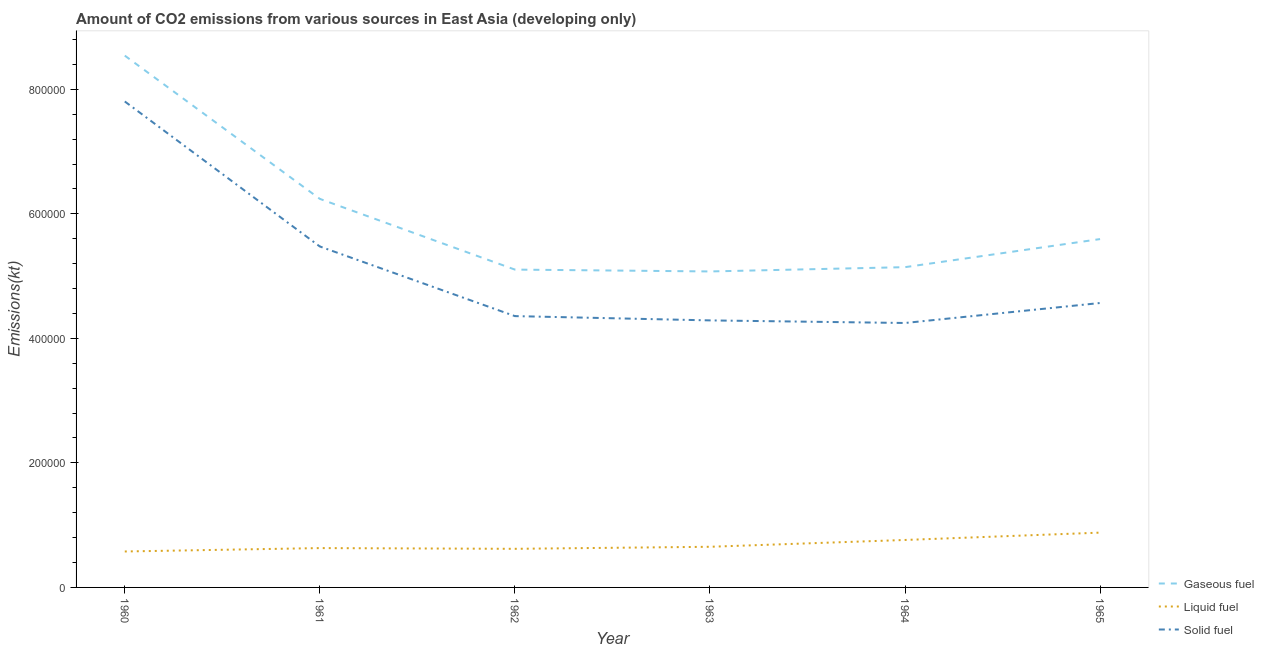Does the line corresponding to amount of co2 emissions from gaseous fuel intersect with the line corresponding to amount of co2 emissions from liquid fuel?
Offer a very short reply. No. Is the number of lines equal to the number of legend labels?
Provide a short and direct response. Yes. What is the amount of co2 emissions from solid fuel in 1962?
Keep it short and to the point. 4.36e+05. Across all years, what is the maximum amount of co2 emissions from gaseous fuel?
Ensure brevity in your answer.  8.54e+05. Across all years, what is the minimum amount of co2 emissions from gaseous fuel?
Offer a very short reply. 5.07e+05. In which year was the amount of co2 emissions from solid fuel maximum?
Keep it short and to the point. 1960. What is the total amount of co2 emissions from liquid fuel in the graph?
Keep it short and to the point. 4.12e+05. What is the difference between the amount of co2 emissions from liquid fuel in 1960 and that in 1965?
Offer a very short reply. -3.03e+04. What is the difference between the amount of co2 emissions from liquid fuel in 1963 and the amount of co2 emissions from gaseous fuel in 1964?
Provide a succinct answer. -4.49e+05. What is the average amount of co2 emissions from gaseous fuel per year?
Offer a terse response. 5.95e+05. In the year 1960, what is the difference between the amount of co2 emissions from gaseous fuel and amount of co2 emissions from solid fuel?
Offer a terse response. 7.36e+04. In how many years, is the amount of co2 emissions from solid fuel greater than 360000 kt?
Your answer should be very brief. 6. What is the ratio of the amount of co2 emissions from solid fuel in 1961 to that in 1962?
Your answer should be very brief. 1.26. Is the difference between the amount of co2 emissions from gaseous fuel in 1963 and 1964 greater than the difference between the amount of co2 emissions from solid fuel in 1963 and 1964?
Make the answer very short. No. What is the difference between the highest and the second highest amount of co2 emissions from gaseous fuel?
Your response must be concise. 2.30e+05. What is the difference between the highest and the lowest amount of co2 emissions from gaseous fuel?
Make the answer very short. 3.47e+05. In how many years, is the amount of co2 emissions from solid fuel greater than the average amount of co2 emissions from solid fuel taken over all years?
Your answer should be very brief. 2. Is the amount of co2 emissions from liquid fuel strictly greater than the amount of co2 emissions from gaseous fuel over the years?
Your response must be concise. No. Is the amount of co2 emissions from gaseous fuel strictly less than the amount of co2 emissions from liquid fuel over the years?
Make the answer very short. No. How many lines are there?
Your answer should be very brief. 3. Are the values on the major ticks of Y-axis written in scientific E-notation?
Your answer should be compact. No. Does the graph contain grids?
Your answer should be compact. No. Where does the legend appear in the graph?
Provide a succinct answer. Bottom right. What is the title of the graph?
Your answer should be very brief. Amount of CO2 emissions from various sources in East Asia (developing only). What is the label or title of the X-axis?
Give a very brief answer. Year. What is the label or title of the Y-axis?
Ensure brevity in your answer.  Emissions(kt). What is the Emissions(kt) of Gaseous fuel in 1960?
Provide a short and direct response. 8.54e+05. What is the Emissions(kt) in Liquid fuel in 1960?
Make the answer very short. 5.77e+04. What is the Emissions(kt) in Solid fuel in 1960?
Offer a very short reply. 7.80e+05. What is the Emissions(kt) in Gaseous fuel in 1961?
Your answer should be compact. 6.24e+05. What is the Emissions(kt) in Liquid fuel in 1961?
Ensure brevity in your answer.  6.32e+04. What is the Emissions(kt) in Solid fuel in 1961?
Provide a succinct answer. 5.48e+05. What is the Emissions(kt) of Gaseous fuel in 1962?
Make the answer very short. 5.10e+05. What is the Emissions(kt) in Liquid fuel in 1962?
Provide a short and direct response. 6.20e+04. What is the Emissions(kt) of Solid fuel in 1962?
Offer a very short reply. 4.36e+05. What is the Emissions(kt) in Gaseous fuel in 1963?
Offer a very short reply. 5.07e+05. What is the Emissions(kt) in Liquid fuel in 1963?
Provide a short and direct response. 6.53e+04. What is the Emissions(kt) in Solid fuel in 1963?
Your response must be concise. 4.29e+05. What is the Emissions(kt) of Gaseous fuel in 1964?
Offer a terse response. 5.14e+05. What is the Emissions(kt) in Liquid fuel in 1964?
Keep it short and to the point. 7.62e+04. What is the Emissions(kt) of Solid fuel in 1964?
Offer a very short reply. 4.25e+05. What is the Emissions(kt) of Gaseous fuel in 1965?
Your answer should be compact. 5.59e+05. What is the Emissions(kt) of Liquid fuel in 1965?
Your answer should be compact. 8.80e+04. What is the Emissions(kt) in Solid fuel in 1965?
Your response must be concise. 4.57e+05. Across all years, what is the maximum Emissions(kt) of Gaseous fuel?
Make the answer very short. 8.54e+05. Across all years, what is the maximum Emissions(kt) of Liquid fuel?
Ensure brevity in your answer.  8.80e+04. Across all years, what is the maximum Emissions(kt) in Solid fuel?
Provide a short and direct response. 7.80e+05. Across all years, what is the minimum Emissions(kt) in Gaseous fuel?
Ensure brevity in your answer.  5.07e+05. Across all years, what is the minimum Emissions(kt) of Liquid fuel?
Provide a short and direct response. 5.77e+04. Across all years, what is the minimum Emissions(kt) of Solid fuel?
Make the answer very short. 4.25e+05. What is the total Emissions(kt) of Gaseous fuel in the graph?
Offer a terse response. 3.57e+06. What is the total Emissions(kt) of Liquid fuel in the graph?
Give a very brief answer. 4.12e+05. What is the total Emissions(kt) in Solid fuel in the graph?
Make the answer very short. 3.07e+06. What is the difference between the Emissions(kt) of Gaseous fuel in 1960 and that in 1961?
Your answer should be very brief. 2.30e+05. What is the difference between the Emissions(kt) of Liquid fuel in 1960 and that in 1961?
Keep it short and to the point. -5450.83. What is the difference between the Emissions(kt) in Solid fuel in 1960 and that in 1961?
Provide a succinct answer. 2.33e+05. What is the difference between the Emissions(kt) of Gaseous fuel in 1960 and that in 1962?
Make the answer very short. 3.44e+05. What is the difference between the Emissions(kt) of Liquid fuel in 1960 and that in 1962?
Make the answer very short. -4268.25. What is the difference between the Emissions(kt) of Solid fuel in 1960 and that in 1962?
Your response must be concise. 3.45e+05. What is the difference between the Emissions(kt) in Gaseous fuel in 1960 and that in 1963?
Make the answer very short. 3.47e+05. What is the difference between the Emissions(kt) in Liquid fuel in 1960 and that in 1963?
Give a very brief answer. -7549.32. What is the difference between the Emissions(kt) of Solid fuel in 1960 and that in 1963?
Ensure brevity in your answer.  3.52e+05. What is the difference between the Emissions(kt) in Gaseous fuel in 1960 and that in 1964?
Ensure brevity in your answer.  3.40e+05. What is the difference between the Emissions(kt) of Liquid fuel in 1960 and that in 1964?
Your response must be concise. -1.85e+04. What is the difference between the Emissions(kt) of Solid fuel in 1960 and that in 1964?
Ensure brevity in your answer.  3.56e+05. What is the difference between the Emissions(kt) in Gaseous fuel in 1960 and that in 1965?
Provide a succinct answer. 2.95e+05. What is the difference between the Emissions(kt) of Liquid fuel in 1960 and that in 1965?
Give a very brief answer. -3.03e+04. What is the difference between the Emissions(kt) in Solid fuel in 1960 and that in 1965?
Keep it short and to the point. 3.24e+05. What is the difference between the Emissions(kt) in Gaseous fuel in 1961 and that in 1962?
Provide a short and direct response. 1.14e+05. What is the difference between the Emissions(kt) of Liquid fuel in 1961 and that in 1962?
Offer a terse response. 1182.58. What is the difference between the Emissions(kt) of Solid fuel in 1961 and that in 1962?
Ensure brevity in your answer.  1.12e+05. What is the difference between the Emissions(kt) in Gaseous fuel in 1961 and that in 1963?
Keep it short and to the point. 1.17e+05. What is the difference between the Emissions(kt) of Liquid fuel in 1961 and that in 1963?
Your answer should be compact. -2098.49. What is the difference between the Emissions(kt) of Solid fuel in 1961 and that in 1963?
Give a very brief answer. 1.19e+05. What is the difference between the Emissions(kt) of Gaseous fuel in 1961 and that in 1964?
Ensure brevity in your answer.  1.10e+05. What is the difference between the Emissions(kt) in Liquid fuel in 1961 and that in 1964?
Ensure brevity in your answer.  -1.30e+04. What is the difference between the Emissions(kt) of Solid fuel in 1961 and that in 1964?
Give a very brief answer. 1.23e+05. What is the difference between the Emissions(kt) of Gaseous fuel in 1961 and that in 1965?
Your answer should be compact. 6.46e+04. What is the difference between the Emissions(kt) of Liquid fuel in 1961 and that in 1965?
Your answer should be very brief. -2.48e+04. What is the difference between the Emissions(kt) of Solid fuel in 1961 and that in 1965?
Your response must be concise. 9.08e+04. What is the difference between the Emissions(kt) of Gaseous fuel in 1962 and that in 1963?
Ensure brevity in your answer.  2970.98. What is the difference between the Emissions(kt) of Liquid fuel in 1962 and that in 1963?
Your answer should be very brief. -3281.07. What is the difference between the Emissions(kt) of Solid fuel in 1962 and that in 1963?
Provide a succinct answer. 6890.94. What is the difference between the Emissions(kt) of Gaseous fuel in 1962 and that in 1964?
Make the answer very short. -3914.56. What is the difference between the Emissions(kt) of Liquid fuel in 1962 and that in 1964?
Make the answer very short. -1.42e+04. What is the difference between the Emissions(kt) in Solid fuel in 1962 and that in 1964?
Make the answer very short. 1.11e+04. What is the difference between the Emissions(kt) in Gaseous fuel in 1962 and that in 1965?
Your answer should be very brief. -4.90e+04. What is the difference between the Emissions(kt) of Liquid fuel in 1962 and that in 1965?
Provide a short and direct response. -2.60e+04. What is the difference between the Emissions(kt) of Solid fuel in 1962 and that in 1965?
Ensure brevity in your answer.  -2.10e+04. What is the difference between the Emissions(kt) in Gaseous fuel in 1963 and that in 1964?
Offer a terse response. -6885.54. What is the difference between the Emissions(kt) in Liquid fuel in 1963 and that in 1964?
Ensure brevity in your answer.  -1.09e+04. What is the difference between the Emissions(kt) in Solid fuel in 1963 and that in 1964?
Make the answer very short. 4162.49. What is the difference between the Emissions(kt) of Gaseous fuel in 1963 and that in 1965?
Provide a short and direct response. -5.20e+04. What is the difference between the Emissions(kt) of Liquid fuel in 1963 and that in 1965?
Your answer should be very brief. -2.27e+04. What is the difference between the Emissions(kt) in Solid fuel in 1963 and that in 1965?
Keep it short and to the point. -2.79e+04. What is the difference between the Emissions(kt) of Gaseous fuel in 1964 and that in 1965?
Provide a short and direct response. -4.51e+04. What is the difference between the Emissions(kt) in Liquid fuel in 1964 and that in 1965?
Provide a short and direct response. -1.18e+04. What is the difference between the Emissions(kt) of Solid fuel in 1964 and that in 1965?
Offer a terse response. -3.21e+04. What is the difference between the Emissions(kt) of Gaseous fuel in 1960 and the Emissions(kt) of Liquid fuel in 1961?
Your answer should be very brief. 7.91e+05. What is the difference between the Emissions(kt) in Gaseous fuel in 1960 and the Emissions(kt) in Solid fuel in 1961?
Your answer should be compact. 3.07e+05. What is the difference between the Emissions(kt) of Liquid fuel in 1960 and the Emissions(kt) of Solid fuel in 1961?
Give a very brief answer. -4.90e+05. What is the difference between the Emissions(kt) in Gaseous fuel in 1960 and the Emissions(kt) in Liquid fuel in 1962?
Your answer should be very brief. 7.92e+05. What is the difference between the Emissions(kt) in Gaseous fuel in 1960 and the Emissions(kt) in Solid fuel in 1962?
Provide a short and direct response. 4.18e+05. What is the difference between the Emissions(kt) of Liquid fuel in 1960 and the Emissions(kt) of Solid fuel in 1962?
Your answer should be very brief. -3.78e+05. What is the difference between the Emissions(kt) of Gaseous fuel in 1960 and the Emissions(kt) of Liquid fuel in 1963?
Make the answer very short. 7.89e+05. What is the difference between the Emissions(kt) of Gaseous fuel in 1960 and the Emissions(kt) of Solid fuel in 1963?
Provide a succinct answer. 4.25e+05. What is the difference between the Emissions(kt) in Liquid fuel in 1960 and the Emissions(kt) in Solid fuel in 1963?
Your response must be concise. -3.71e+05. What is the difference between the Emissions(kt) in Gaseous fuel in 1960 and the Emissions(kt) in Liquid fuel in 1964?
Give a very brief answer. 7.78e+05. What is the difference between the Emissions(kt) in Gaseous fuel in 1960 and the Emissions(kt) in Solid fuel in 1964?
Ensure brevity in your answer.  4.29e+05. What is the difference between the Emissions(kt) in Liquid fuel in 1960 and the Emissions(kt) in Solid fuel in 1964?
Provide a short and direct response. -3.67e+05. What is the difference between the Emissions(kt) in Gaseous fuel in 1960 and the Emissions(kt) in Liquid fuel in 1965?
Keep it short and to the point. 7.66e+05. What is the difference between the Emissions(kt) of Gaseous fuel in 1960 and the Emissions(kt) of Solid fuel in 1965?
Provide a succinct answer. 3.97e+05. What is the difference between the Emissions(kt) in Liquid fuel in 1960 and the Emissions(kt) in Solid fuel in 1965?
Keep it short and to the point. -3.99e+05. What is the difference between the Emissions(kt) of Gaseous fuel in 1961 and the Emissions(kt) of Liquid fuel in 1962?
Keep it short and to the point. 5.62e+05. What is the difference between the Emissions(kt) in Gaseous fuel in 1961 and the Emissions(kt) in Solid fuel in 1962?
Offer a very short reply. 1.88e+05. What is the difference between the Emissions(kt) in Liquid fuel in 1961 and the Emissions(kt) in Solid fuel in 1962?
Your answer should be compact. -3.73e+05. What is the difference between the Emissions(kt) in Gaseous fuel in 1961 and the Emissions(kt) in Liquid fuel in 1963?
Ensure brevity in your answer.  5.59e+05. What is the difference between the Emissions(kt) of Gaseous fuel in 1961 and the Emissions(kt) of Solid fuel in 1963?
Ensure brevity in your answer.  1.95e+05. What is the difference between the Emissions(kt) in Liquid fuel in 1961 and the Emissions(kt) in Solid fuel in 1963?
Your answer should be very brief. -3.66e+05. What is the difference between the Emissions(kt) of Gaseous fuel in 1961 and the Emissions(kt) of Liquid fuel in 1964?
Offer a terse response. 5.48e+05. What is the difference between the Emissions(kt) in Gaseous fuel in 1961 and the Emissions(kt) in Solid fuel in 1964?
Offer a terse response. 1.99e+05. What is the difference between the Emissions(kt) of Liquid fuel in 1961 and the Emissions(kt) of Solid fuel in 1964?
Your response must be concise. -3.62e+05. What is the difference between the Emissions(kt) of Gaseous fuel in 1961 and the Emissions(kt) of Liquid fuel in 1965?
Your answer should be compact. 5.36e+05. What is the difference between the Emissions(kt) in Gaseous fuel in 1961 and the Emissions(kt) in Solid fuel in 1965?
Make the answer very short. 1.67e+05. What is the difference between the Emissions(kt) of Liquid fuel in 1961 and the Emissions(kt) of Solid fuel in 1965?
Your response must be concise. -3.94e+05. What is the difference between the Emissions(kt) in Gaseous fuel in 1962 and the Emissions(kt) in Liquid fuel in 1963?
Offer a very short reply. 4.45e+05. What is the difference between the Emissions(kt) in Gaseous fuel in 1962 and the Emissions(kt) in Solid fuel in 1963?
Your answer should be compact. 8.16e+04. What is the difference between the Emissions(kt) in Liquid fuel in 1962 and the Emissions(kt) in Solid fuel in 1963?
Your answer should be very brief. -3.67e+05. What is the difference between the Emissions(kt) of Gaseous fuel in 1962 and the Emissions(kt) of Liquid fuel in 1964?
Your answer should be very brief. 4.34e+05. What is the difference between the Emissions(kt) of Gaseous fuel in 1962 and the Emissions(kt) of Solid fuel in 1964?
Ensure brevity in your answer.  8.58e+04. What is the difference between the Emissions(kt) in Liquid fuel in 1962 and the Emissions(kt) in Solid fuel in 1964?
Your response must be concise. -3.63e+05. What is the difference between the Emissions(kt) of Gaseous fuel in 1962 and the Emissions(kt) of Liquid fuel in 1965?
Make the answer very short. 4.22e+05. What is the difference between the Emissions(kt) of Gaseous fuel in 1962 and the Emissions(kt) of Solid fuel in 1965?
Ensure brevity in your answer.  5.37e+04. What is the difference between the Emissions(kt) of Liquid fuel in 1962 and the Emissions(kt) of Solid fuel in 1965?
Your response must be concise. -3.95e+05. What is the difference between the Emissions(kt) of Gaseous fuel in 1963 and the Emissions(kt) of Liquid fuel in 1964?
Provide a succinct answer. 4.31e+05. What is the difference between the Emissions(kt) in Gaseous fuel in 1963 and the Emissions(kt) in Solid fuel in 1964?
Offer a terse response. 8.28e+04. What is the difference between the Emissions(kt) in Liquid fuel in 1963 and the Emissions(kt) in Solid fuel in 1964?
Provide a succinct answer. -3.59e+05. What is the difference between the Emissions(kt) in Gaseous fuel in 1963 and the Emissions(kt) in Liquid fuel in 1965?
Make the answer very short. 4.19e+05. What is the difference between the Emissions(kt) of Gaseous fuel in 1963 and the Emissions(kt) of Solid fuel in 1965?
Provide a succinct answer. 5.07e+04. What is the difference between the Emissions(kt) of Liquid fuel in 1963 and the Emissions(kt) of Solid fuel in 1965?
Provide a succinct answer. -3.92e+05. What is the difference between the Emissions(kt) of Gaseous fuel in 1964 and the Emissions(kt) of Liquid fuel in 1965?
Provide a short and direct response. 4.26e+05. What is the difference between the Emissions(kt) of Gaseous fuel in 1964 and the Emissions(kt) of Solid fuel in 1965?
Provide a succinct answer. 5.76e+04. What is the difference between the Emissions(kt) of Liquid fuel in 1964 and the Emissions(kt) of Solid fuel in 1965?
Your answer should be compact. -3.81e+05. What is the average Emissions(kt) of Gaseous fuel per year?
Provide a short and direct response. 5.95e+05. What is the average Emissions(kt) of Liquid fuel per year?
Ensure brevity in your answer.  6.87e+04. What is the average Emissions(kt) in Solid fuel per year?
Make the answer very short. 5.12e+05. In the year 1960, what is the difference between the Emissions(kt) in Gaseous fuel and Emissions(kt) in Liquid fuel?
Offer a terse response. 7.96e+05. In the year 1960, what is the difference between the Emissions(kt) of Gaseous fuel and Emissions(kt) of Solid fuel?
Give a very brief answer. 7.36e+04. In the year 1960, what is the difference between the Emissions(kt) in Liquid fuel and Emissions(kt) in Solid fuel?
Your response must be concise. -7.23e+05. In the year 1961, what is the difference between the Emissions(kt) in Gaseous fuel and Emissions(kt) in Liquid fuel?
Provide a succinct answer. 5.61e+05. In the year 1961, what is the difference between the Emissions(kt) of Gaseous fuel and Emissions(kt) of Solid fuel?
Your answer should be compact. 7.65e+04. In the year 1961, what is the difference between the Emissions(kt) in Liquid fuel and Emissions(kt) in Solid fuel?
Provide a short and direct response. -4.84e+05. In the year 1962, what is the difference between the Emissions(kt) of Gaseous fuel and Emissions(kt) of Liquid fuel?
Your answer should be very brief. 4.48e+05. In the year 1962, what is the difference between the Emissions(kt) in Gaseous fuel and Emissions(kt) in Solid fuel?
Give a very brief answer. 7.47e+04. In the year 1962, what is the difference between the Emissions(kt) of Liquid fuel and Emissions(kt) of Solid fuel?
Keep it short and to the point. -3.74e+05. In the year 1963, what is the difference between the Emissions(kt) in Gaseous fuel and Emissions(kt) in Liquid fuel?
Offer a terse response. 4.42e+05. In the year 1963, what is the difference between the Emissions(kt) of Gaseous fuel and Emissions(kt) of Solid fuel?
Your answer should be very brief. 7.86e+04. In the year 1963, what is the difference between the Emissions(kt) of Liquid fuel and Emissions(kt) of Solid fuel?
Make the answer very short. -3.64e+05. In the year 1964, what is the difference between the Emissions(kt) in Gaseous fuel and Emissions(kt) in Liquid fuel?
Offer a very short reply. 4.38e+05. In the year 1964, what is the difference between the Emissions(kt) in Gaseous fuel and Emissions(kt) in Solid fuel?
Your response must be concise. 8.97e+04. In the year 1964, what is the difference between the Emissions(kt) of Liquid fuel and Emissions(kt) of Solid fuel?
Your response must be concise. -3.48e+05. In the year 1965, what is the difference between the Emissions(kt) of Gaseous fuel and Emissions(kt) of Liquid fuel?
Give a very brief answer. 4.71e+05. In the year 1965, what is the difference between the Emissions(kt) of Gaseous fuel and Emissions(kt) of Solid fuel?
Give a very brief answer. 1.03e+05. In the year 1965, what is the difference between the Emissions(kt) in Liquid fuel and Emissions(kt) in Solid fuel?
Give a very brief answer. -3.69e+05. What is the ratio of the Emissions(kt) in Gaseous fuel in 1960 to that in 1961?
Your response must be concise. 1.37. What is the ratio of the Emissions(kt) in Liquid fuel in 1960 to that in 1961?
Keep it short and to the point. 0.91. What is the ratio of the Emissions(kt) in Solid fuel in 1960 to that in 1961?
Make the answer very short. 1.43. What is the ratio of the Emissions(kt) of Gaseous fuel in 1960 to that in 1962?
Offer a terse response. 1.67. What is the ratio of the Emissions(kt) in Liquid fuel in 1960 to that in 1962?
Offer a terse response. 0.93. What is the ratio of the Emissions(kt) of Solid fuel in 1960 to that in 1962?
Offer a terse response. 1.79. What is the ratio of the Emissions(kt) of Gaseous fuel in 1960 to that in 1963?
Give a very brief answer. 1.68. What is the ratio of the Emissions(kt) of Liquid fuel in 1960 to that in 1963?
Provide a short and direct response. 0.88. What is the ratio of the Emissions(kt) in Solid fuel in 1960 to that in 1963?
Keep it short and to the point. 1.82. What is the ratio of the Emissions(kt) of Gaseous fuel in 1960 to that in 1964?
Offer a terse response. 1.66. What is the ratio of the Emissions(kt) of Liquid fuel in 1960 to that in 1964?
Provide a succinct answer. 0.76. What is the ratio of the Emissions(kt) in Solid fuel in 1960 to that in 1964?
Keep it short and to the point. 1.84. What is the ratio of the Emissions(kt) in Gaseous fuel in 1960 to that in 1965?
Offer a very short reply. 1.53. What is the ratio of the Emissions(kt) of Liquid fuel in 1960 to that in 1965?
Your response must be concise. 0.66. What is the ratio of the Emissions(kt) in Solid fuel in 1960 to that in 1965?
Make the answer very short. 1.71. What is the ratio of the Emissions(kt) in Gaseous fuel in 1961 to that in 1962?
Your response must be concise. 1.22. What is the ratio of the Emissions(kt) of Liquid fuel in 1961 to that in 1962?
Provide a short and direct response. 1.02. What is the ratio of the Emissions(kt) in Solid fuel in 1961 to that in 1962?
Provide a succinct answer. 1.26. What is the ratio of the Emissions(kt) of Gaseous fuel in 1961 to that in 1963?
Ensure brevity in your answer.  1.23. What is the ratio of the Emissions(kt) of Liquid fuel in 1961 to that in 1963?
Give a very brief answer. 0.97. What is the ratio of the Emissions(kt) in Solid fuel in 1961 to that in 1963?
Offer a very short reply. 1.28. What is the ratio of the Emissions(kt) of Gaseous fuel in 1961 to that in 1964?
Give a very brief answer. 1.21. What is the ratio of the Emissions(kt) of Liquid fuel in 1961 to that in 1964?
Make the answer very short. 0.83. What is the ratio of the Emissions(kt) in Solid fuel in 1961 to that in 1964?
Keep it short and to the point. 1.29. What is the ratio of the Emissions(kt) in Gaseous fuel in 1961 to that in 1965?
Provide a succinct answer. 1.12. What is the ratio of the Emissions(kt) of Liquid fuel in 1961 to that in 1965?
Give a very brief answer. 0.72. What is the ratio of the Emissions(kt) in Solid fuel in 1961 to that in 1965?
Provide a succinct answer. 1.2. What is the ratio of the Emissions(kt) of Gaseous fuel in 1962 to that in 1963?
Provide a succinct answer. 1.01. What is the ratio of the Emissions(kt) in Liquid fuel in 1962 to that in 1963?
Provide a short and direct response. 0.95. What is the ratio of the Emissions(kt) of Solid fuel in 1962 to that in 1963?
Ensure brevity in your answer.  1.02. What is the ratio of the Emissions(kt) in Liquid fuel in 1962 to that in 1964?
Your answer should be very brief. 0.81. What is the ratio of the Emissions(kt) in Solid fuel in 1962 to that in 1964?
Keep it short and to the point. 1.03. What is the ratio of the Emissions(kt) of Gaseous fuel in 1962 to that in 1965?
Offer a terse response. 0.91. What is the ratio of the Emissions(kt) of Liquid fuel in 1962 to that in 1965?
Give a very brief answer. 0.7. What is the ratio of the Emissions(kt) of Solid fuel in 1962 to that in 1965?
Offer a very short reply. 0.95. What is the ratio of the Emissions(kt) in Gaseous fuel in 1963 to that in 1964?
Offer a very short reply. 0.99. What is the ratio of the Emissions(kt) of Liquid fuel in 1963 to that in 1964?
Provide a succinct answer. 0.86. What is the ratio of the Emissions(kt) in Solid fuel in 1963 to that in 1964?
Offer a very short reply. 1.01. What is the ratio of the Emissions(kt) of Gaseous fuel in 1963 to that in 1965?
Your answer should be compact. 0.91. What is the ratio of the Emissions(kt) of Liquid fuel in 1963 to that in 1965?
Provide a short and direct response. 0.74. What is the ratio of the Emissions(kt) in Solid fuel in 1963 to that in 1965?
Make the answer very short. 0.94. What is the ratio of the Emissions(kt) of Gaseous fuel in 1964 to that in 1965?
Provide a succinct answer. 0.92. What is the ratio of the Emissions(kt) in Liquid fuel in 1964 to that in 1965?
Keep it short and to the point. 0.87. What is the ratio of the Emissions(kt) of Solid fuel in 1964 to that in 1965?
Provide a succinct answer. 0.93. What is the difference between the highest and the second highest Emissions(kt) in Gaseous fuel?
Provide a succinct answer. 2.30e+05. What is the difference between the highest and the second highest Emissions(kt) of Liquid fuel?
Give a very brief answer. 1.18e+04. What is the difference between the highest and the second highest Emissions(kt) of Solid fuel?
Keep it short and to the point. 2.33e+05. What is the difference between the highest and the lowest Emissions(kt) in Gaseous fuel?
Offer a very short reply. 3.47e+05. What is the difference between the highest and the lowest Emissions(kt) of Liquid fuel?
Keep it short and to the point. 3.03e+04. What is the difference between the highest and the lowest Emissions(kt) in Solid fuel?
Provide a short and direct response. 3.56e+05. 